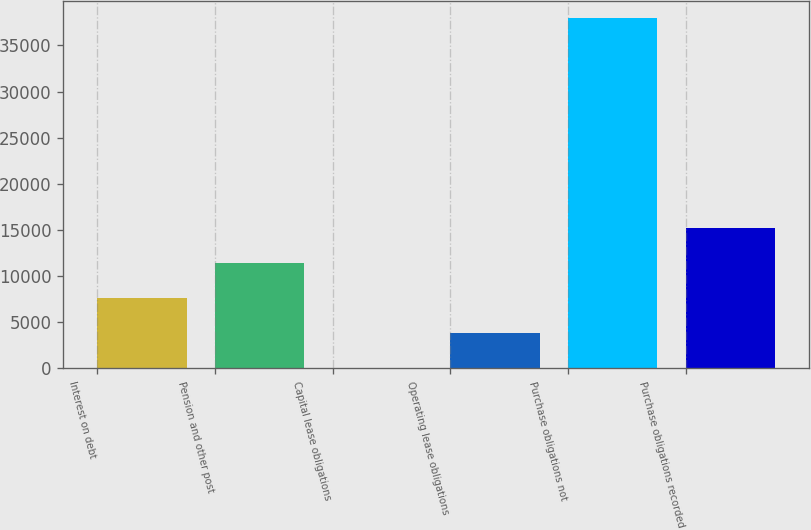Convert chart. <chart><loc_0><loc_0><loc_500><loc_500><bar_chart><fcel>Interest on debt<fcel>Pension and other post<fcel>Capital lease obligations<fcel>Operating lease obligations<fcel>Purchase obligations not<fcel>Purchase obligations recorded<nl><fcel>7599.6<fcel>11389.9<fcel>19<fcel>3809.3<fcel>37922<fcel>15180.2<nl></chart> 